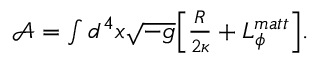Convert formula to latex. <formula><loc_0><loc_0><loc_500><loc_500>\begin{array} { r } { \mathcal { A } = \int d ^ { 4 } x \sqrt { - g } \left [ \frac { R } { 2 \kappa } + L _ { \phi } ^ { m a t t } \right ] . } \end{array}</formula> 